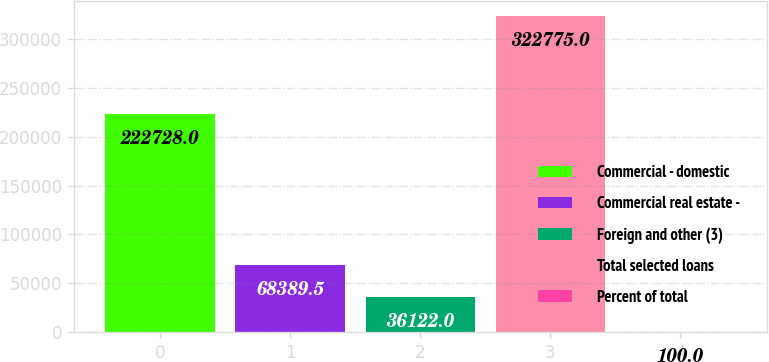<chart> <loc_0><loc_0><loc_500><loc_500><bar_chart><fcel>Commercial - domestic<fcel>Commercial real estate -<fcel>Foreign and other (3)<fcel>Total selected loans<fcel>Percent of total<nl><fcel>222728<fcel>68389.5<fcel>36122<fcel>322775<fcel>100<nl></chart> 